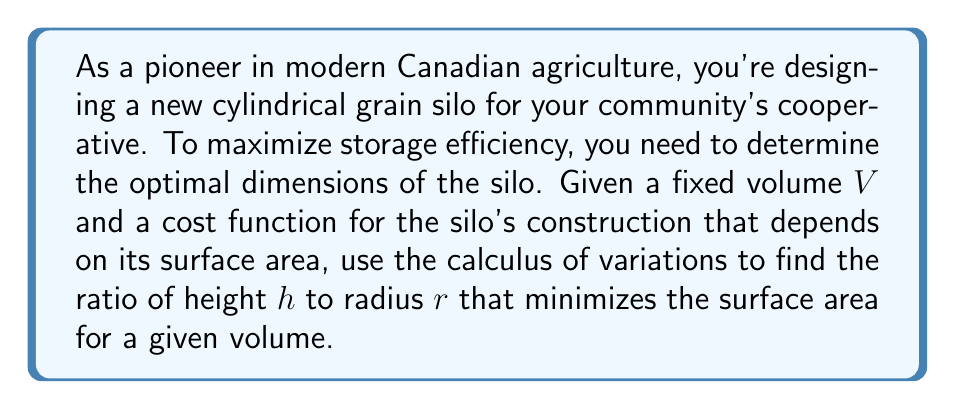Help me with this question. Let's approach this step-by-step:

1) The volume of a cylinder is given by:
   $$V = \pi r^2 h$$

2) The surface area of a cylinder (including top and bottom) is:
   $$S = 2\pi r^2 + 2\pi r h$$

3) We want to minimize S subject to the constraint that V is constant. We can use the method of Lagrange multipliers:

4) Define the Lagrangian:
   $$L(r, h, \lambda) = S - \lambda(V - \pi r^2 h)$$

5) Take partial derivatives and set them to zero:

   $$\frac{\partial L}{\partial r} = 4\pi r + 2\pi h + 2\lambda \pi r h = 0$$
   $$\frac{\partial L}{\partial h} = 2\pi r - \lambda \pi r^2 = 0$$
   $$\frac{\partial L}{\partial \lambda} = V - \pi r^2 h = 0$$

6) From the second equation:
   $$\lambda = \frac{2}{r}$$

7) Substitute this into the first equation:
   $$4\pi r + 2\pi h + 2\frac{2}{r} \pi r h = 0$$
   $$4r + 2h + 4h = 0$$
   $$4r + 6h = 0$$
   $$2r + 3h = 0$$
   $$h = -\frac{2r}{3}$$

8) The negative sign doesn't make physical sense, so we take the absolute value:
   $$h = \frac{2r}{3}$$

9) This gives us the optimal ratio of height to radius:
   $$\frac{h}{r} = \frac{2}{3}$$
Answer: $\frac{h}{r} = \frac{2}{3}$ 